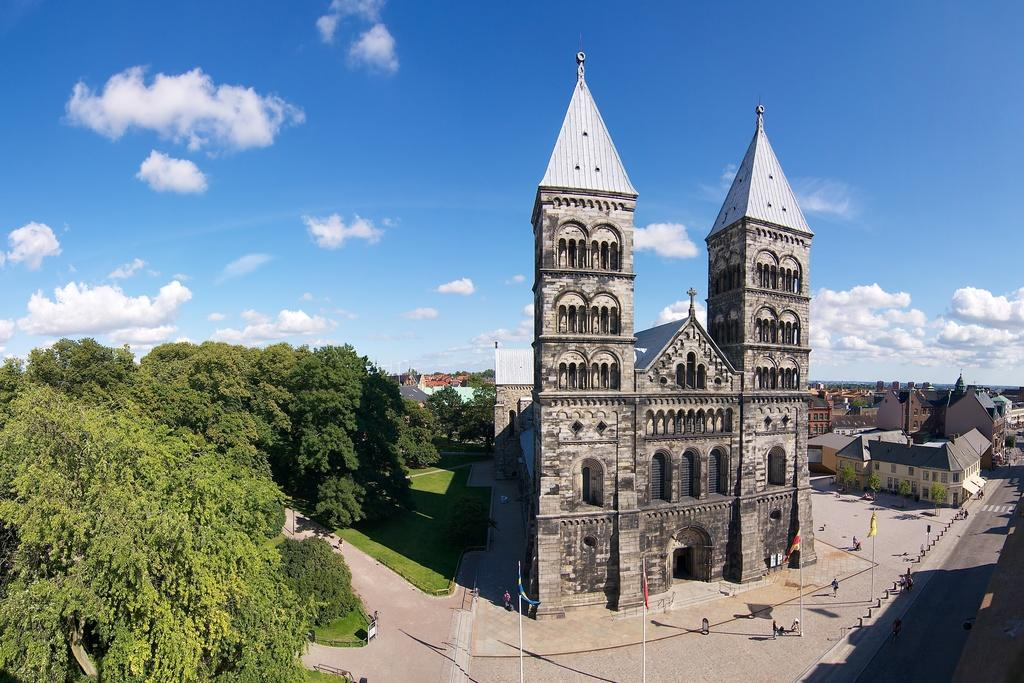What type of structure can be seen in the image? There is a building in the image. Are there any residential structures in the image? Yes, there are houses in the image. What are the vertical structures in the image used for? There are poles in the image, which are likely used for supporting wires or other infrastructure. What is attached to the poles in the image? There are flags attached to the poles in the image. What type of vegetation is present in the image? There is grass and trees in the image. Are there any people visible in the image? Yes, there are persons in the image. What is visible in the background of the image? The sky is visible in the background of the image, and there are clouds in the sky. Where is the button located in the image? There is no button present in the image. What type of drawer can be seen in the image in the image? There is no drawer present in the image. 